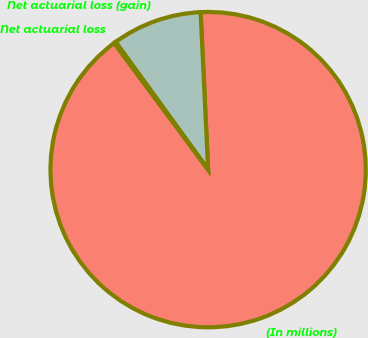<chart> <loc_0><loc_0><loc_500><loc_500><pie_chart><fcel>(In millions)<fcel>Net actuarial loss (gain)<fcel>Net actuarial loss<nl><fcel>90.6%<fcel>9.22%<fcel>0.18%<nl></chart> 